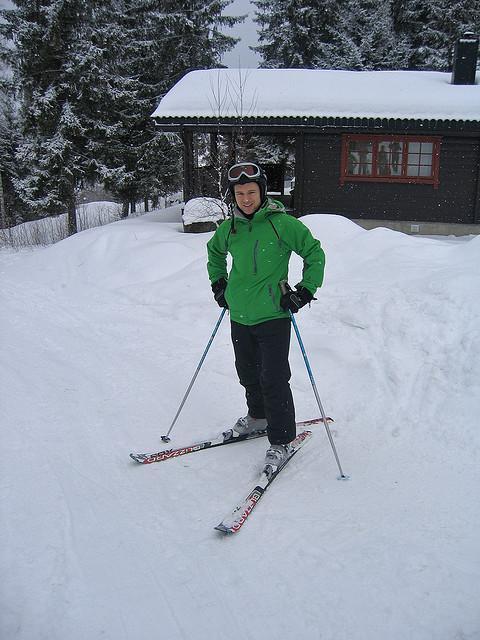How many trains are shown?
Give a very brief answer. 0. 